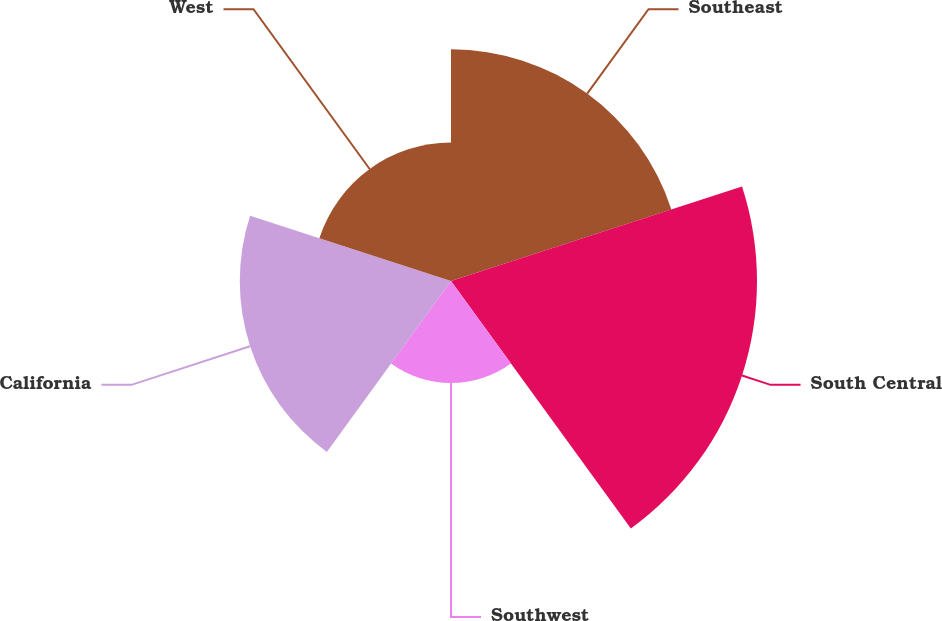Convert chart. <chart><loc_0><loc_0><loc_500><loc_500><pie_chart><fcel>Southeast<fcel>South Central<fcel>Southwest<fcel>California<fcel>West<nl><fcel>23.42%<fcel>30.93%<fcel>10.31%<fcel>21.35%<fcel>13.99%<nl></chart> 